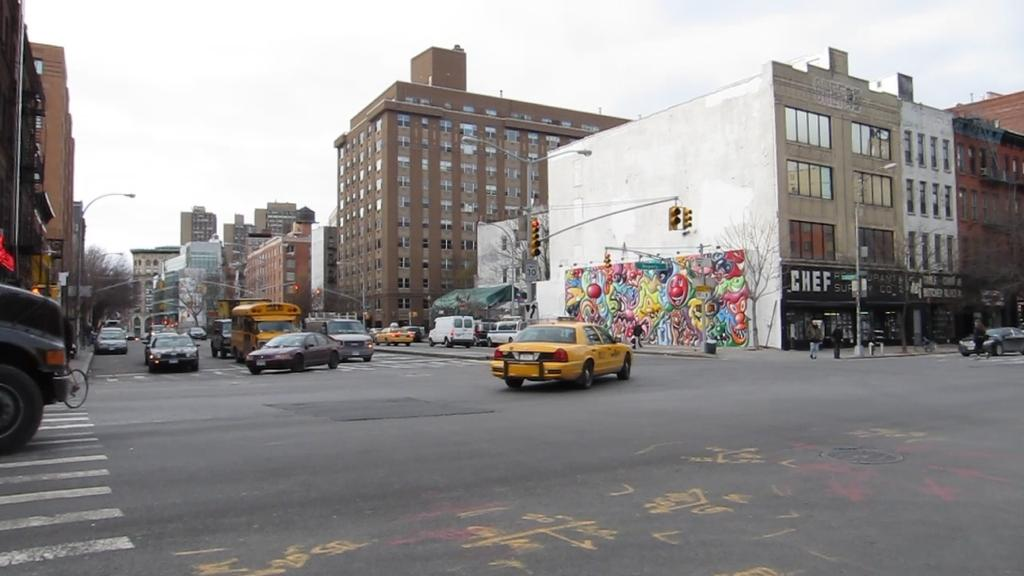<image>
Render a clear and concise summary of the photo. A large colorful mural is painted on the side of the building where the Chef Supply Company is located. 